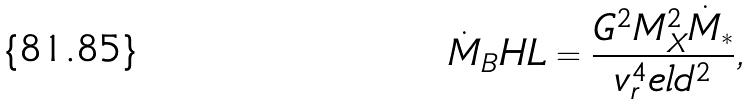Convert formula to latex. <formula><loc_0><loc_0><loc_500><loc_500>\dot { M } _ { B } H L = \frac { G ^ { 2 } M ^ { 2 } _ { X } \dot { M } _ { * } } { v ^ { 4 } _ { r } e l d ^ { 2 } } ,</formula> 